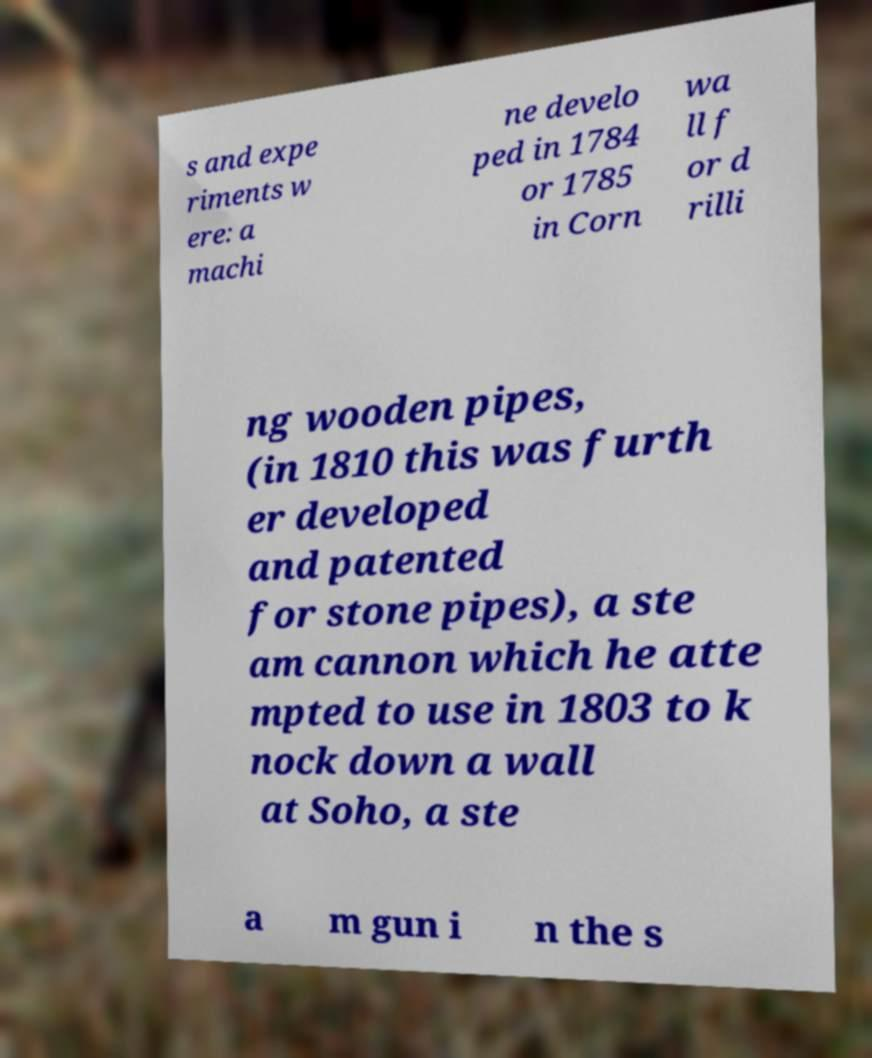Could you extract and type out the text from this image? s and expe riments w ere: a machi ne develo ped in 1784 or 1785 in Corn wa ll f or d rilli ng wooden pipes, (in 1810 this was furth er developed and patented for stone pipes), a ste am cannon which he atte mpted to use in 1803 to k nock down a wall at Soho, a ste a m gun i n the s 